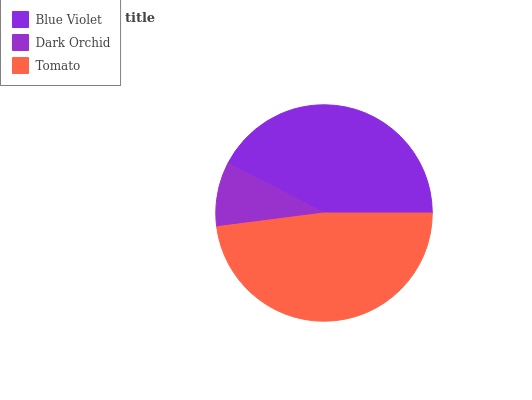Is Dark Orchid the minimum?
Answer yes or no. Yes. Is Tomato the maximum?
Answer yes or no. Yes. Is Tomato the minimum?
Answer yes or no. No. Is Dark Orchid the maximum?
Answer yes or no. No. Is Tomato greater than Dark Orchid?
Answer yes or no. Yes. Is Dark Orchid less than Tomato?
Answer yes or no. Yes. Is Dark Orchid greater than Tomato?
Answer yes or no. No. Is Tomato less than Dark Orchid?
Answer yes or no. No. Is Blue Violet the high median?
Answer yes or no. Yes. Is Blue Violet the low median?
Answer yes or no. Yes. Is Tomato the high median?
Answer yes or no. No. Is Dark Orchid the low median?
Answer yes or no. No. 